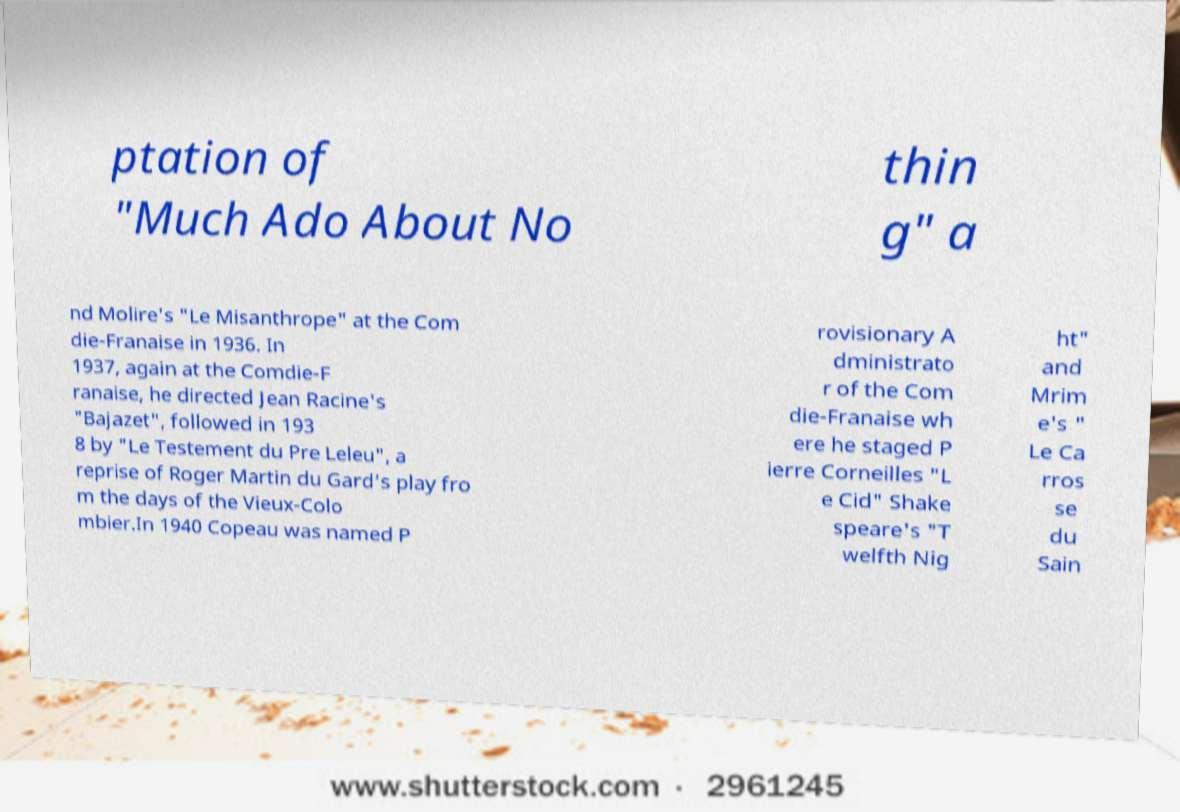I need the written content from this picture converted into text. Can you do that? ptation of "Much Ado About No thin g" a nd Molire's "Le Misanthrope" at the Com die-Franaise in 1936. In 1937, again at the Comdie-F ranaise, he directed Jean Racine's "Bajazet", followed in 193 8 by "Le Testement du Pre Leleu", a reprise of Roger Martin du Gard's play fro m the days of the Vieux-Colo mbier.In 1940 Copeau was named P rovisionary A dministrato r of the Com die-Franaise wh ere he staged P ierre Corneilles "L e Cid" Shake speare's "T welfth Nig ht" and Mrim e's " Le Ca rros se du Sain 